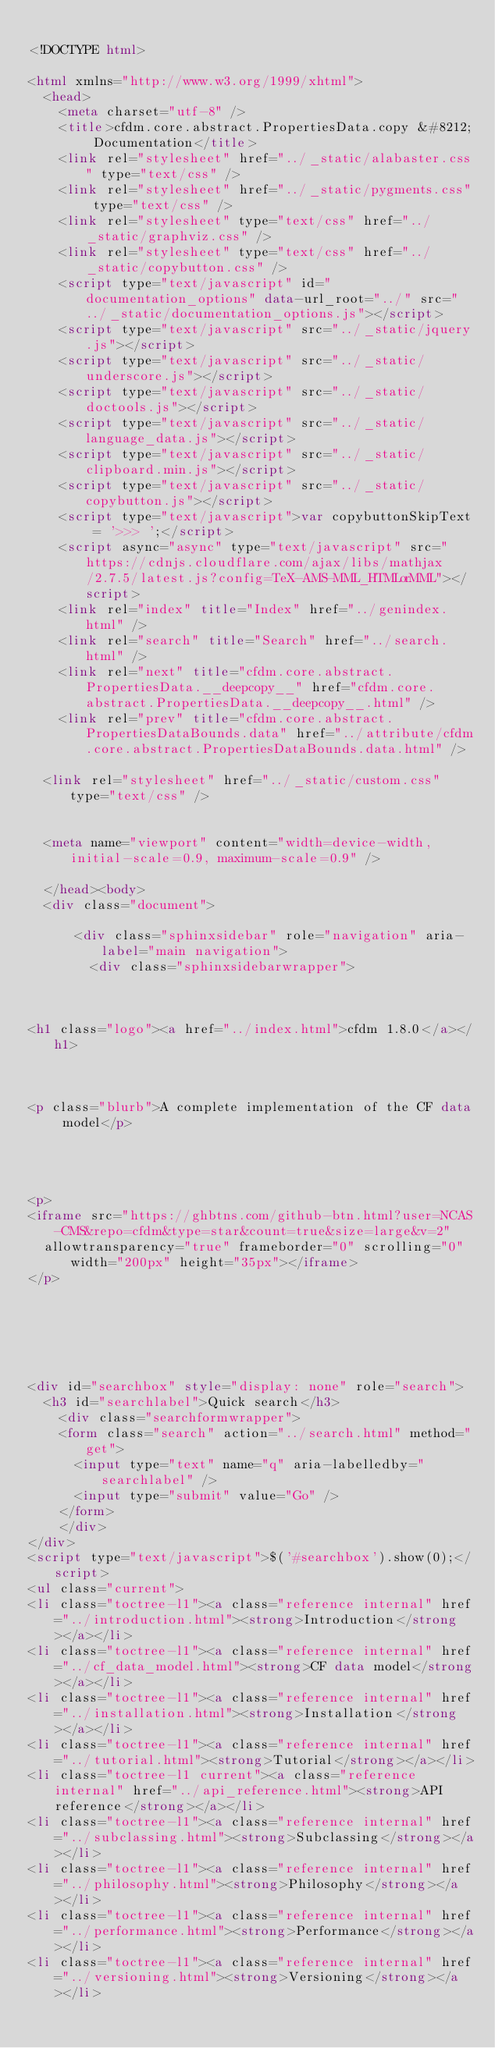<code> <loc_0><loc_0><loc_500><loc_500><_HTML_>
<!DOCTYPE html>

<html xmlns="http://www.w3.org/1999/xhtml">
  <head>
    <meta charset="utf-8" />
    <title>cfdm.core.abstract.PropertiesData.copy &#8212; Documentation</title>
    <link rel="stylesheet" href="../_static/alabaster.css" type="text/css" />
    <link rel="stylesheet" href="../_static/pygments.css" type="text/css" />
    <link rel="stylesheet" type="text/css" href="../_static/graphviz.css" />
    <link rel="stylesheet" type="text/css" href="../_static/copybutton.css" />
    <script type="text/javascript" id="documentation_options" data-url_root="../" src="../_static/documentation_options.js"></script>
    <script type="text/javascript" src="../_static/jquery.js"></script>
    <script type="text/javascript" src="../_static/underscore.js"></script>
    <script type="text/javascript" src="../_static/doctools.js"></script>
    <script type="text/javascript" src="../_static/language_data.js"></script>
    <script type="text/javascript" src="../_static/clipboard.min.js"></script>
    <script type="text/javascript" src="../_static/copybutton.js"></script>
    <script type="text/javascript">var copybuttonSkipText = '>>> ';</script>
    <script async="async" type="text/javascript" src="https://cdnjs.cloudflare.com/ajax/libs/mathjax/2.7.5/latest.js?config=TeX-AMS-MML_HTMLorMML"></script>
    <link rel="index" title="Index" href="../genindex.html" />
    <link rel="search" title="Search" href="../search.html" />
    <link rel="next" title="cfdm.core.abstract.PropertiesData.__deepcopy__" href="cfdm.core.abstract.PropertiesData.__deepcopy__.html" />
    <link rel="prev" title="cfdm.core.abstract.PropertiesDataBounds.data" href="../attribute/cfdm.core.abstract.PropertiesDataBounds.data.html" />
   
  <link rel="stylesheet" href="../_static/custom.css" type="text/css" />
  
  
  <meta name="viewport" content="width=device-width, initial-scale=0.9, maximum-scale=0.9" />

  </head><body>
  <div class="document">
    
      <div class="sphinxsidebar" role="navigation" aria-label="main navigation">
        <div class="sphinxsidebarwrapper">



<h1 class="logo"><a href="../index.html">cfdm 1.8.0</a></h1>



<p class="blurb">A complete implementation of the CF data model</p>




<p>
<iframe src="https://ghbtns.com/github-btn.html?user=NCAS-CMS&repo=cfdm&type=star&count=true&size=large&v=2"
  allowtransparency="true" frameborder="0" scrolling="0" width="200px" height="35px"></iframe>
</p>






<div id="searchbox" style="display: none" role="search">
  <h3 id="searchlabel">Quick search</h3>
    <div class="searchformwrapper">
    <form class="search" action="../search.html" method="get">
      <input type="text" name="q" aria-labelledby="searchlabel" />
      <input type="submit" value="Go" />
    </form>
    </div>
</div>
<script type="text/javascript">$('#searchbox').show(0);</script>
<ul class="current">
<li class="toctree-l1"><a class="reference internal" href="../introduction.html"><strong>Introduction</strong></a></li>
<li class="toctree-l1"><a class="reference internal" href="../cf_data_model.html"><strong>CF data model</strong></a></li>
<li class="toctree-l1"><a class="reference internal" href="../installation.html"><strong>Installation</strong></a></li>
<li class="toctree-l1"><a class="reference internal" href="../tutorial.html"><strong>Tutorial</strong></a></li>
<li class="toctree-l1 current"><a class="reference internal" href="../api_reference.html"><strong>API reference</strong></a></li>
<li class="toctree-l1"><a class="reference internal" href="../subclassing.html"><strong>Subclassing</strong></a></li>
<li class="toctree-l1"><a class="reference internal" href="../philosophy.html"><strong>Philosophy</strong></a></li>
<li class="toctree-l1"><a class="reference internal" href="../performance.html"><strong>Performance</strong></a></li>
<li class="toctree-l1"><a class="reference internal" href="../versioning.html"><strong>Versioning</strong></a></li></code> 